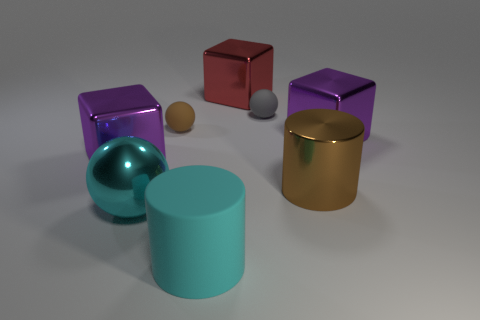What is the shape of the object that is both behind the tiny brown sphere and to the right of the red object?
Provide a succinct answer. Sphere. What material is the large cyan cylinder?
Your answer should be compact. Rubber. How many cubes are big metallic objects or cyan things?
Your answer should be very brief. 3. Does the large sphere have the same material as the red block?
Make the answer very short. Yes. There is a brown thing that is the same shape as the tiny gray rubber object; what is its size?
Ensure brevity in your answer.  Small. There is a big object that is left of the cyan matte cylinder and behind the large brown metallic cylinder; what is it made of?
Keep it short and to the point. Metal. Is the number of red blocks that are left of the large cyan metallic object the same as the number of tiny brown metal balls?
Offer a very short reply. Yes. What number of objects are large purple metal objects to the left of the tiny gray sphere or large metallic cubes?
Your response must be concise. 3. There is a big cylinder that is to the left of the big brown cylinder; does it have the same color as the metallic sphere?
Your answer should be compact. Yes. How big is the rubber thing that is in front of the big cyan shiny sphere?
Your answer should be very brief. Large. 